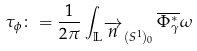<formula> <loc_0><loc_0><loc_500><loc_500>\tau _ { \phi } \colon = \frac { 1 } { 2 \pi } \int _ { \mathbb { L } ^ { \overrightarrow { n } } ( S ^ { 1 } ) _ { 0 } } \overline { \Phi ^ { * } _ { \gamma } } \omega</formula> 